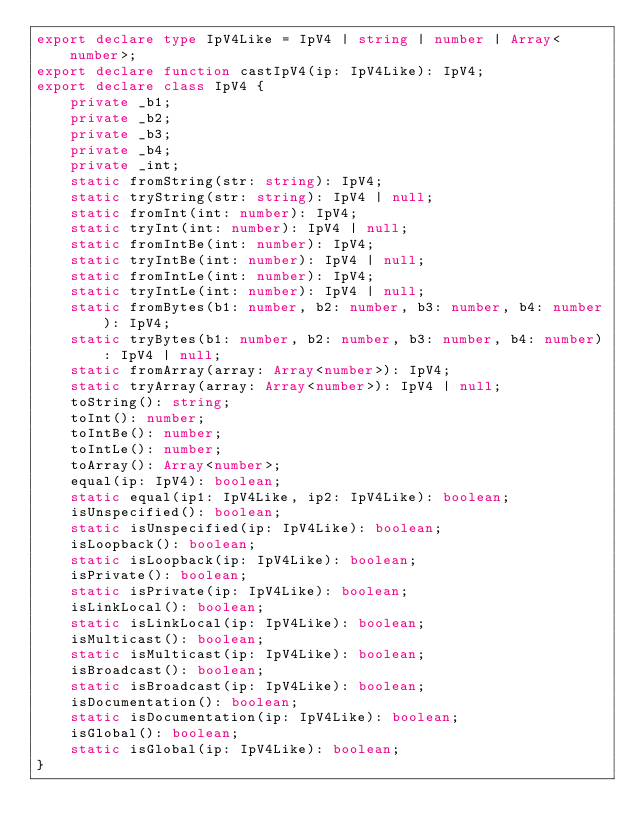Convert code to text. <code><loc_0><loc_0><loc_500><loc_500><_TypeScript_>export declare type IpV4Like = IpV4 | string | number | Array<number>;
export declare function castIpV4(ip: IpV4Like): IpV4;
export declare class IpV4 {
    private _b1;
    private _b2;
    private _b3;
    private _b4;
    private _int;
    static fromString(str: string): IpV4;
    static tryString(str: string): IpV4 | null;
    static fromInt(int: number): IpV4;
    static tryInt(int: number): IpV4 | null;
    static fromIntBe(int: number): IpV4;
    static tryIntBe(int: number): IpV4 | null;
    static fromIntLe(int: number): IpV4;
    static tryIntLe(int: number): IpV4 | null;
    static fromBytes(b1: number, b2: number, b3: number, b4: number): IpV4;
    static tryBytes(b1: number, b2: number, b3: number, b4: number): IpV4 | null;
    static fromArray(array: Array<number>): IpV4;
    static tryArray(array: Array<number>): IpV4 | null;
    toString(): string;
    toInt(): number;
    toIntBe(): number;
    toIntLe(): number;
    toArray(): Array<number>;
    equal(ip: IpV4): boolean;
    static equal(ip1: IpV4Like, ip2: IpV4Like): boolean;
    isUnspecified(): boolean;
    static isUnspecified(ip: IpV4Like): boolean;
    isLoopback(): boolean;
    static isLoopback(ip: IpV4Like): boolean;
    isPrivate(): boolean;
    static isPrivate(ip: IpV4Like): boolean;
    isLinkLocal(): boolean;
    static isLinkLocal(ip: IpV4Like): boolean;
    isMulticast(): boolean;
    static isMulticast(ip: IpV4Like): boolean;
    isBroadcast(): boolean;
    static isBroadcast(ip: IpV4Like): boolean;
    isDocumentation(): boolean;
    static isDocumentation(ip: IpV4Like): boolean;
    isGlobal(): boolean;
    static isGlobal(ip: IpV4Like): boolean;
}
</code> 